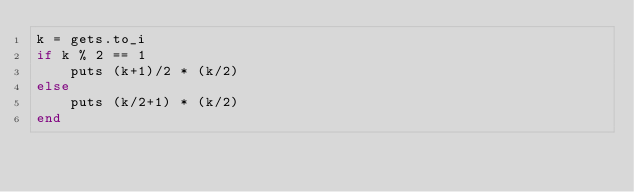<code> <loc_0><loc_0><loc_500><loc_500><_Ruby_>k = gets.to_i
if k % 2 == 1
    puts (k+1)/2 * (k/2)
else
    puts (k/2+1) * (k/2)
end</code> 